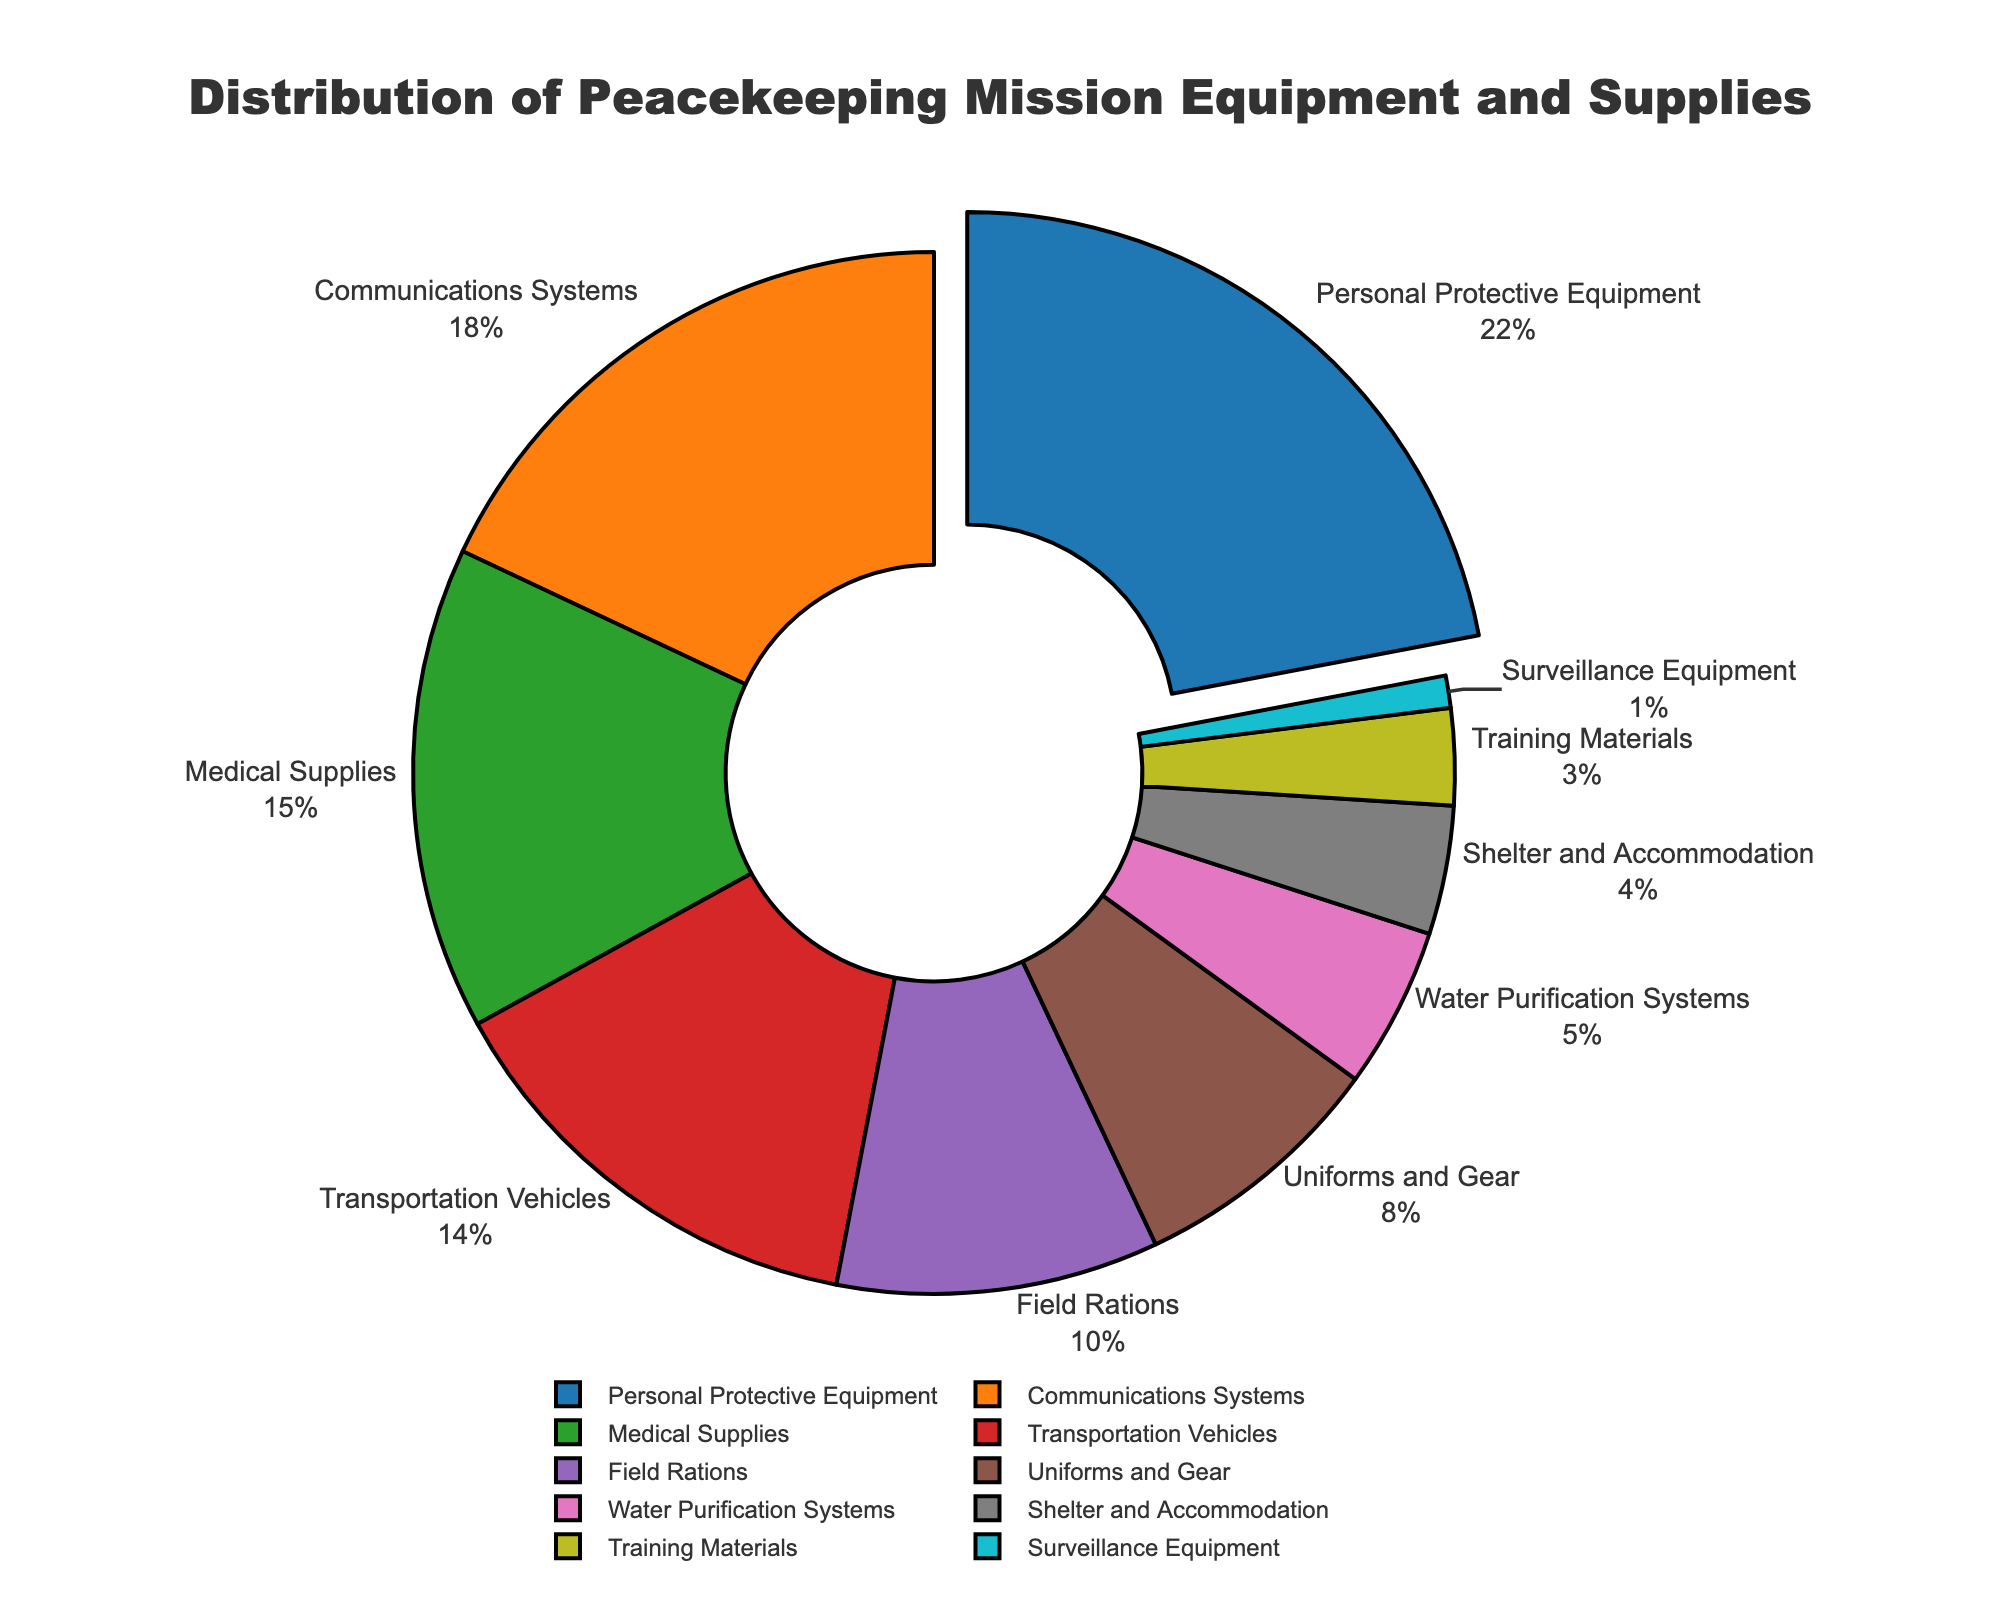What category has the highest expenditure percentage? The largest expenditure percentage can be identified as the category that has the highest value among all the slices in the pie chart. In this chart, Personal Protective Equipment has the highest percentage at 22%.
Answer: Personal Protective Equipment What is the total percentage of expenditure for Medical Supplies and Field Rations combined? To find the combined expenditure, add the percentages of Medical Supplies and Field Rations. Medical Supplies are 15% and Field Rations are 10%, so the total is 15 + 10 = 25%.
Answer: 25% Which category spends more, Communications Systems or Transportation Vehicles? Compare the percentages of Communications Systems and Transportation Vehicles. Communications Systems have 18%, and Transportation Vehicles have 14%. Therefore, Communications Systems spend more.
Answer: Communications Systems What is the difference in expenditure percentage between Uniforms and Gear and Water Purification Systems? To find the difference, subtract the smaller percentage from the larger one. Uniforms and Gear are 8%, and Water Purification Systems are 5%, so the difference is 8 - 5 = 3%.
Answer: 3% How many categories have an expenditure percentage less than 10%? Count the slices in the pie chart with less than 10% expenditure. Categories with percentages less than 10% are Uniforms and Gear (8%), Water Purification Systems (5%), Shelter and Accommodation (4%), Training Materials (3%), and Surveillance Equipment (1%). This is a total of 5 categories.
Answer: 5 If the total budget for peacekeeping mission equipment and supplies is $5 million, what amount is allocated to Transportation Vehicles? Calculate the amount allocated by using the percentage share of the category. Transportation Vehicles have 14%, so the amount is 14% of $5 million, which translates to (14/100) * 5,000,000 = $700,000.
Answer: $700,000 What is the combined percentage of expenditure for categories that spend 5% or less? Add the percentages of all categories with 5% or less expenditure. These categories are Water Purification Systems (5%), Shelter and Accommodation (4%), Training Materials (3%), and Surveillance Equipment (1%). The combined percentage is 5 + 4 + 3 + 1 = 13%.
Answer: 13% Which category has the least expenditure percentage, and what is it? Identify the smallest slice in the pie chart, which is the category with the least expenditure percentage. Surveillance Equipment has the least expenditure at 1%.
Answer: Surveillance Equipment, 1% What is the expenditure percentage difference between Personal Protective Equipment and Medical Supplies? Subtract the expenditure percentage of Medical Supplies from that of Personal Protective Equipment. Personal Protective Equipment is 22%, and Medical Supplies is 15%, so the difference is 22 - 15 = 7%.
Answer: 7% Among the listed categories, how many have an expenditure percentage between 10% and 20%? Count the slices in the pie chart with expenditure percentages between 10% and 20%. The categories are Communications Systems (18%), Medical Supplies (15%), and Transportation Vehicles (14%). This results in a total of 3 categories.
Answer: 3 